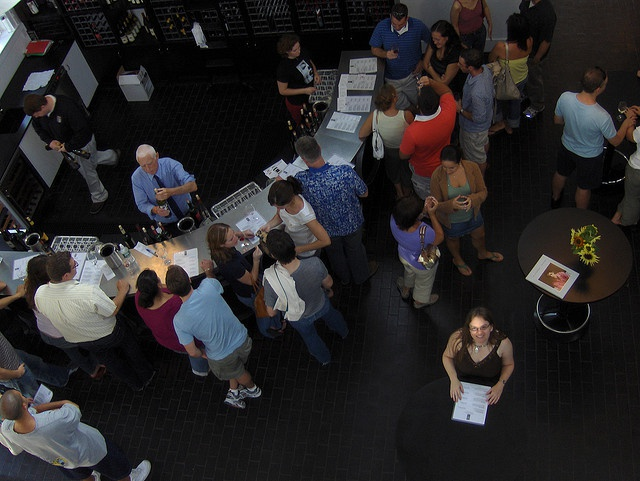Describe the objects in this image and their specific colors. I can see people in lightgray, black, gray, maroon, and darkgray tones, dining table in lightgray, black, darkgray, maroon, and olive tones, people in lightgray, black, darkgray, and gray tones, people in lightgray, gray, and black tones, and people in lightgray, black, navy, gray, and darkblue tones in this image. 